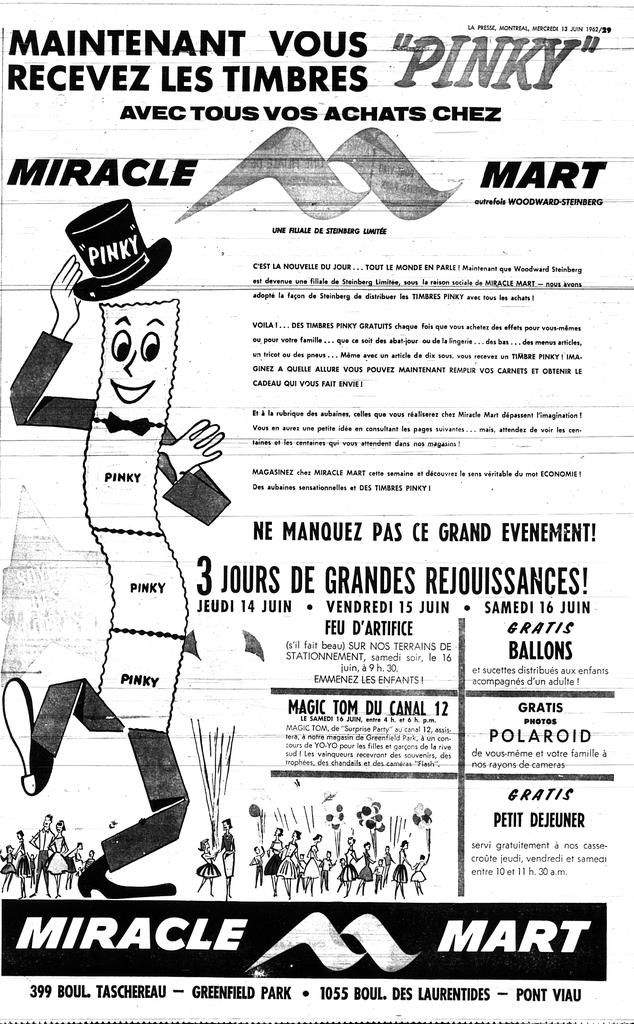What type of image is the main subject of the picture? The image appears to be a promotional poster. Can you describe the text on the poster? There is a lot of text on the poster. What else can be seen on the poster besides the text? There are images on the poster. How many tickets are visible in the image? There are no tickets present in the image. What type of room is shown in the image? There is no room shown in the image; it is a promotional poster with text and images. 